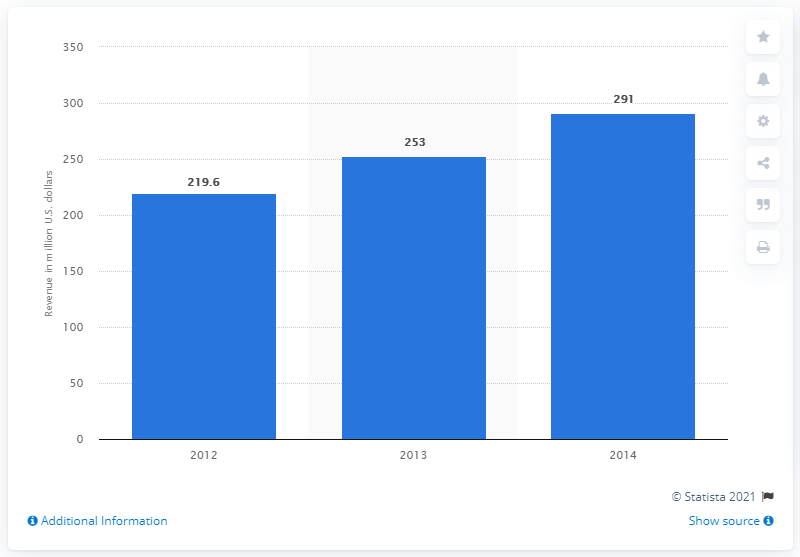Give some essential details in this illustration. The estimated revenue for online PC games in Vietnam in 2014 was approximately 291 million US dollars. 